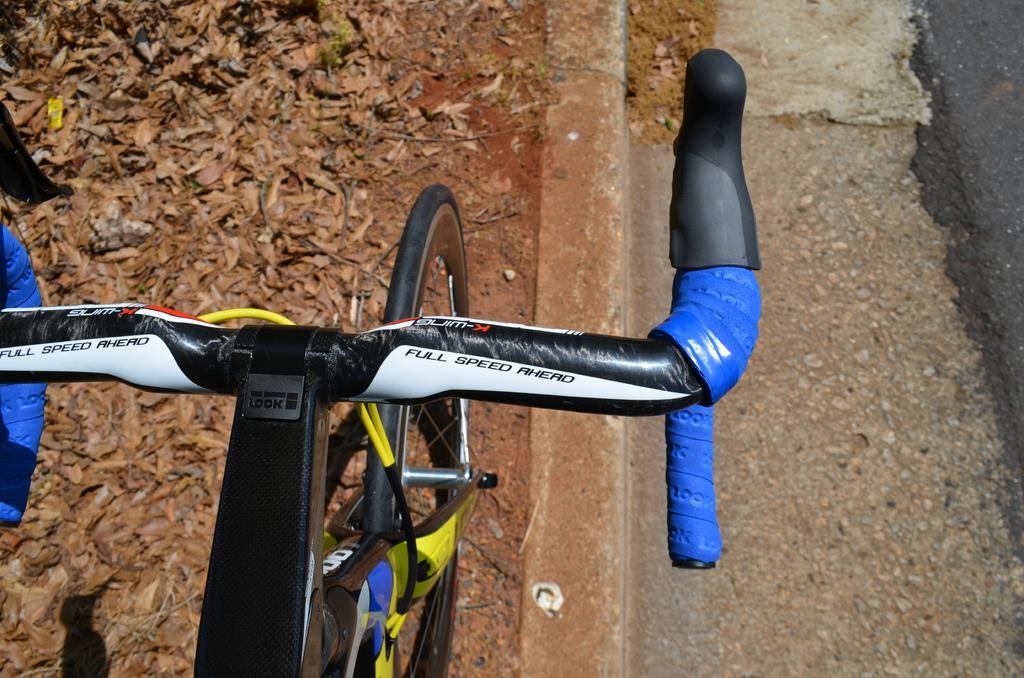In one or two sentences, can you explain what this image depicts? In this picture we can see a bicycle handle and on the path there is a bicycle wheel and some dry leaves. 